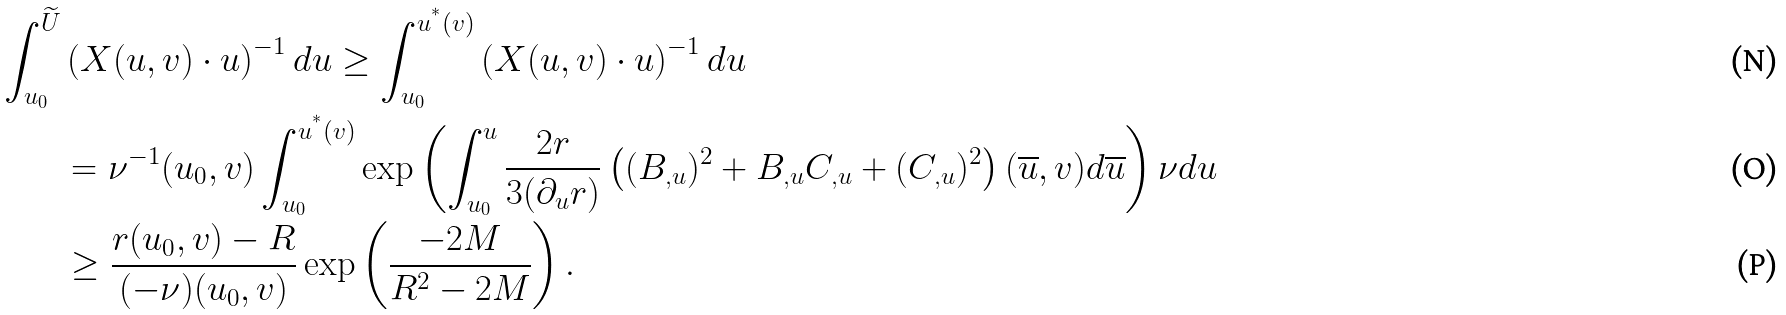Convert formula to latex. <formula><loc_0><loc_0><loc_500><loc_500>\int _ { u _ { 0 } } ^ { \widetilde { U } } & \left ( X ( u , v ) \cdot u \right ) ^ { - 1 } d u \geq \int _ { u _ { 0 } } ^ { u ^ { ^ { * } } ( v ) } \left ( X ( u , v ) \cdot u \right ) ^ { - 1 } d u \\ & = \nu ^ { - 1 } ( u _ { 0 } , v ) \int _ { u _ { 0 } } ^ { u ^ { ^ { * } } ( v ) } \exp \left ( \int _ { u _ { 0 } } ^ { u } \frac { 2 r } { 3 ( \partial _ { u } r ) } \left ( ( B _ { , u } ) ^ { 2 } + B _ { , u } C _ { , u } + ( C _ { , u } ) ^ { 2 } \right ) ( \overline { u } , v ) d \overline { u } \right ) \nu d u \\ & \geq \frac { r ( u _ { 0 } , v ) - R } { ( - \nu ) ( u _ { 0 } , v ) } \exp \left ( \frac { - 2 M } { R ^ { 2 } - 2 M } \right ) .</formula> 